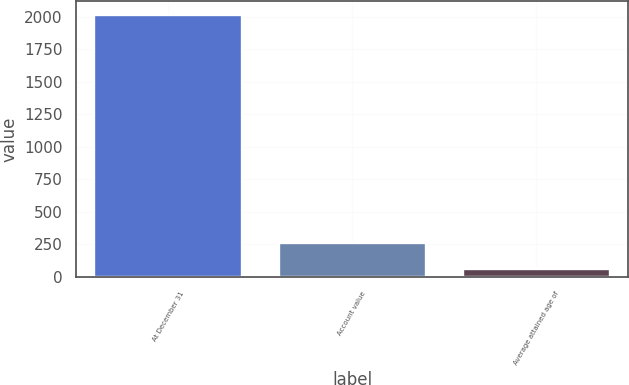<chart> <loc_0><loc_0><loc_500><loc_500><bar_chart><fcel>At December 31<fcel>Account value<fcel>Average attained age of<nl><fcel>2017<fcel>258.4<fcel>63<nl></chart> 